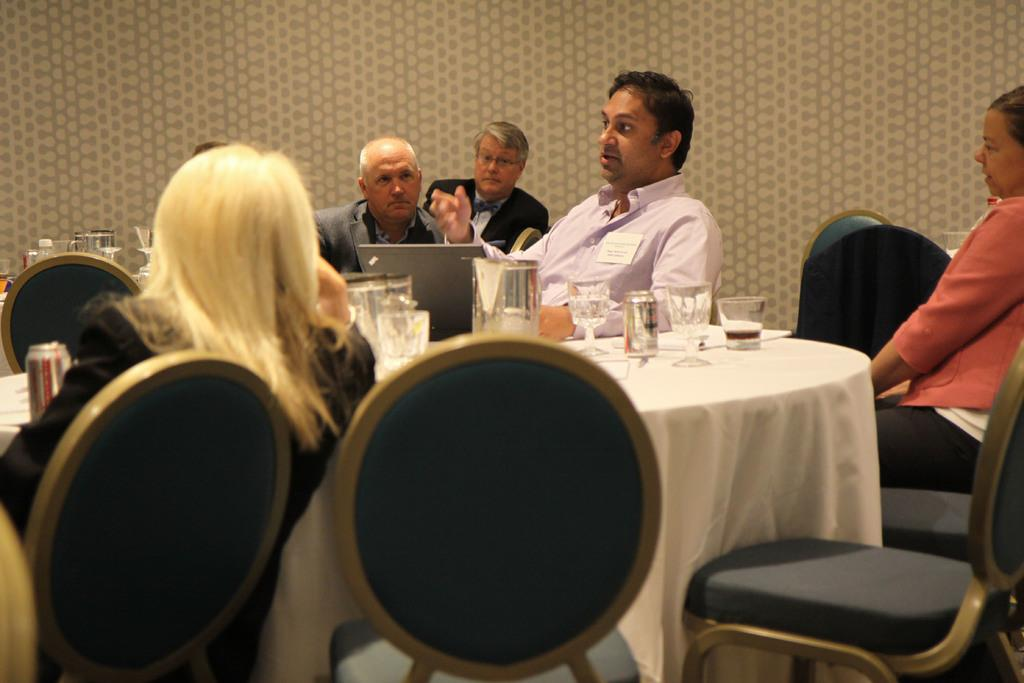What is happening in the image involving a group of people? There is a man speaking in the image, and a group of people is likely listening to him. What object is in front of the man who is speaking? There is a laptop in front of the man who is speaking. What can be seen on the table in the image? There are glasses on the table in the image. How many cows are present in the image? There are no cows present in the image. What type of station is depicted in the image? There is no station depicted in the image. 